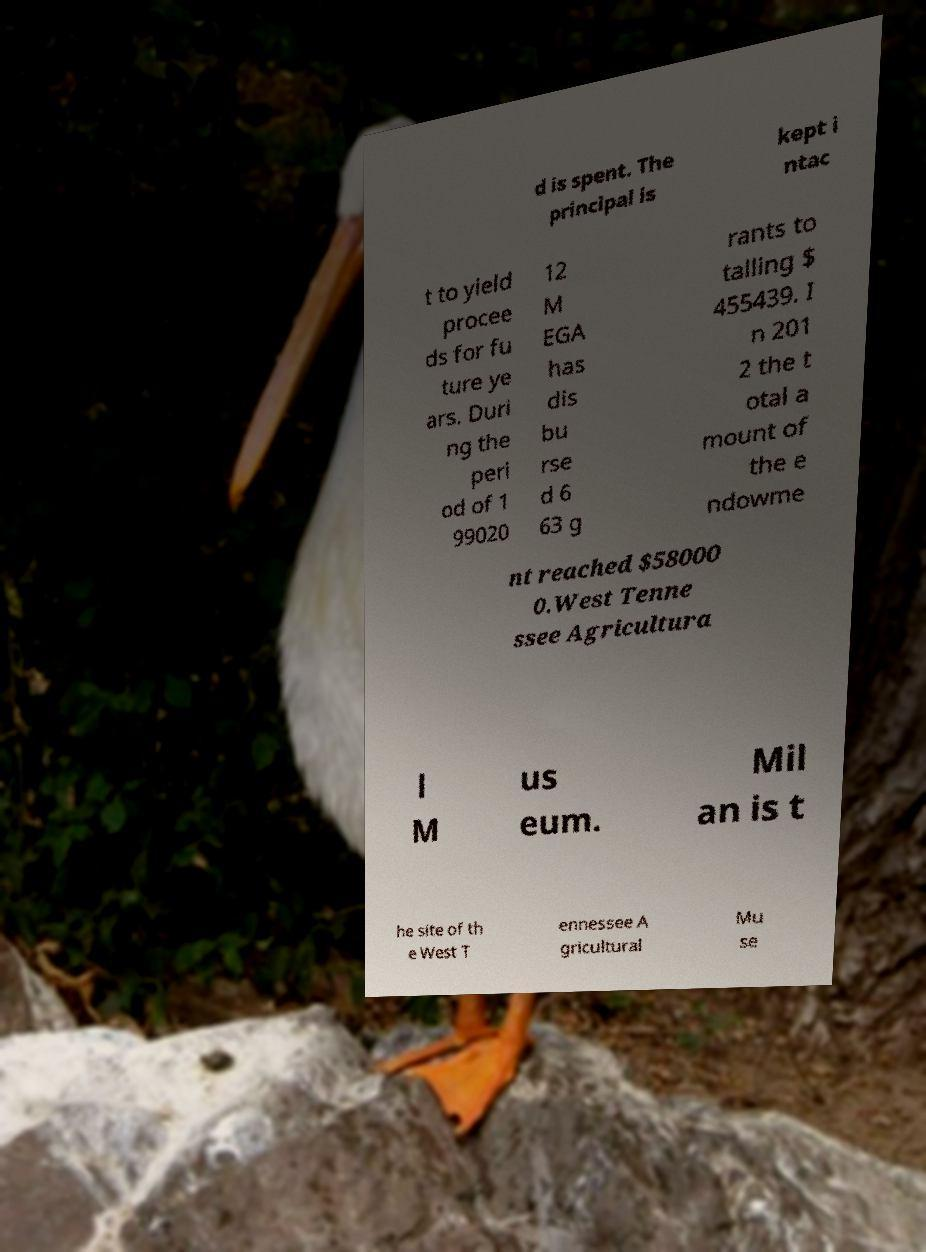There's text embedded in this image that I need extracted. Can you transcribe it verbatim? d is spent. The principal is kept i ntac t to yield procee ds for fu ture ye ars. Duri ng the peri od of 1 99020 12 M EGA has dis bu rse d 6 63 g rants to talling $ 455439. I n 201 2 the t otal a mount of the e ndowme nt reached $58000 0.West Tenne ssee Agricultura l M us eum. Mil an is t he site of th e West T ennessee A gricultural Mu se 